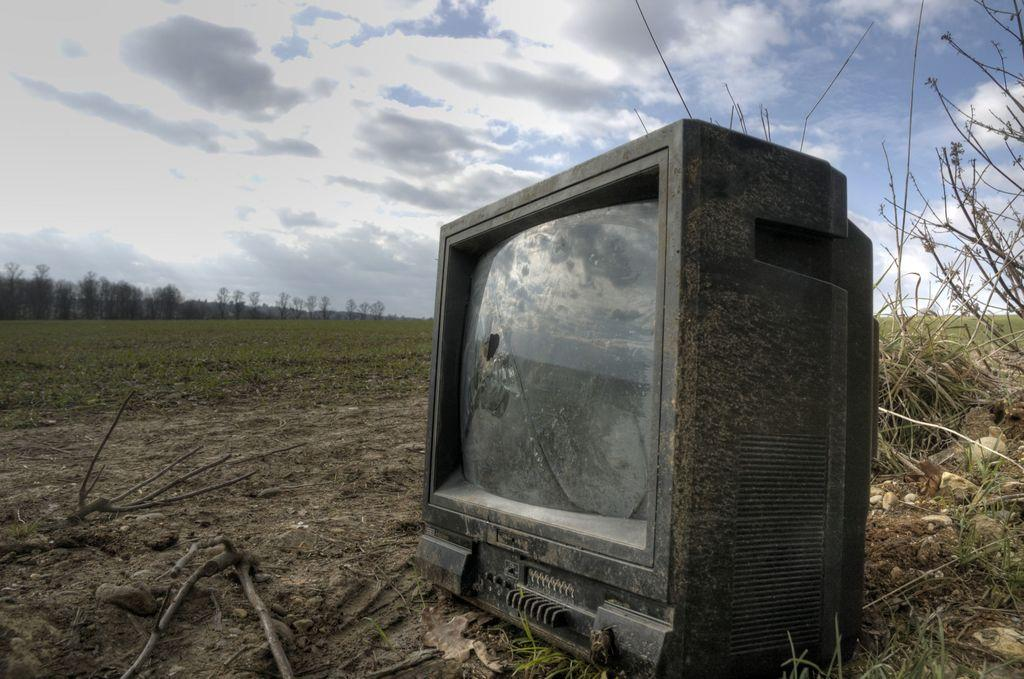What is the condition of the television in the image? The television in the image is damaged. What type of natural elements can be seen in the image? Branches, plants, grass, and trees are visible in the image. What is the sky's condition in the background of the image? Clouds are present in the sky in the background of the image. How does the television learn to fly in the image? The television does not learn to fly in the image, as it is a damaged television and not capable of flight. 